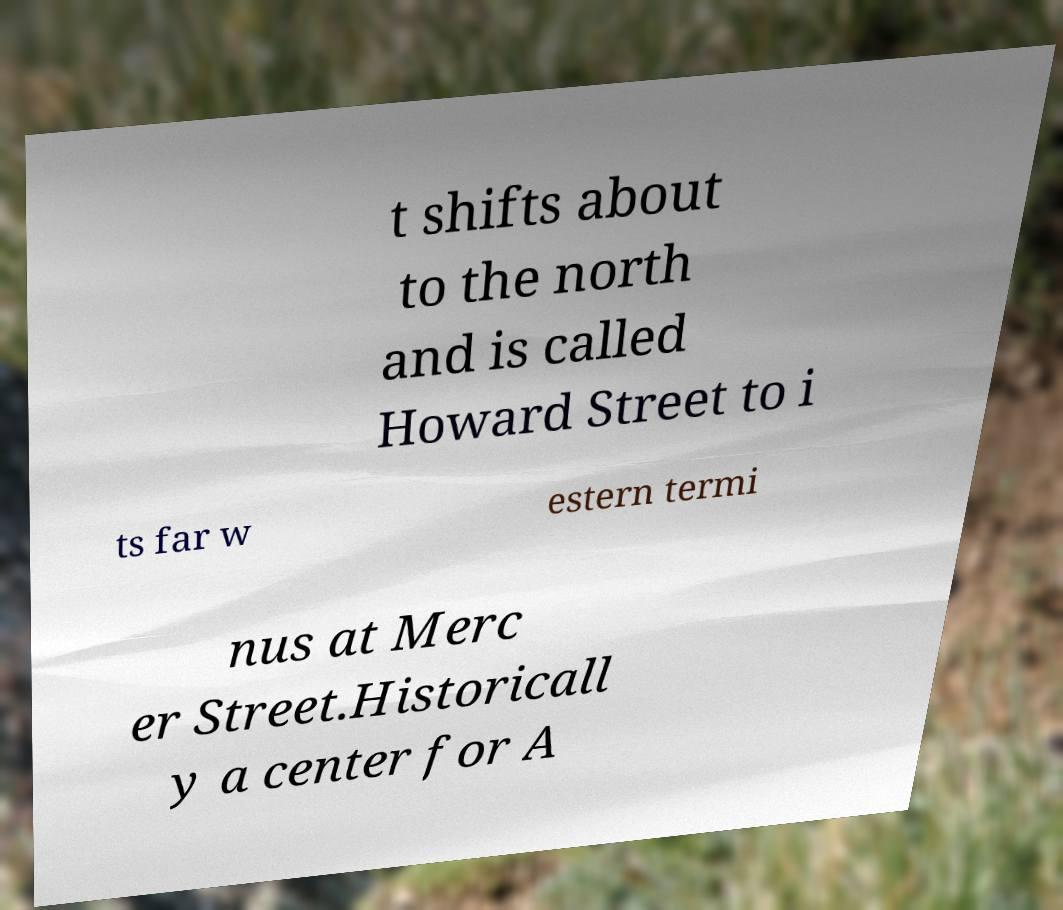For documentation purposes, I need the text within this image transcribed. Could you provide that? t shifts about to the north and is called Howard Street to i ts far w estern termi nus at Merc er Street.Historicall y a center for A 